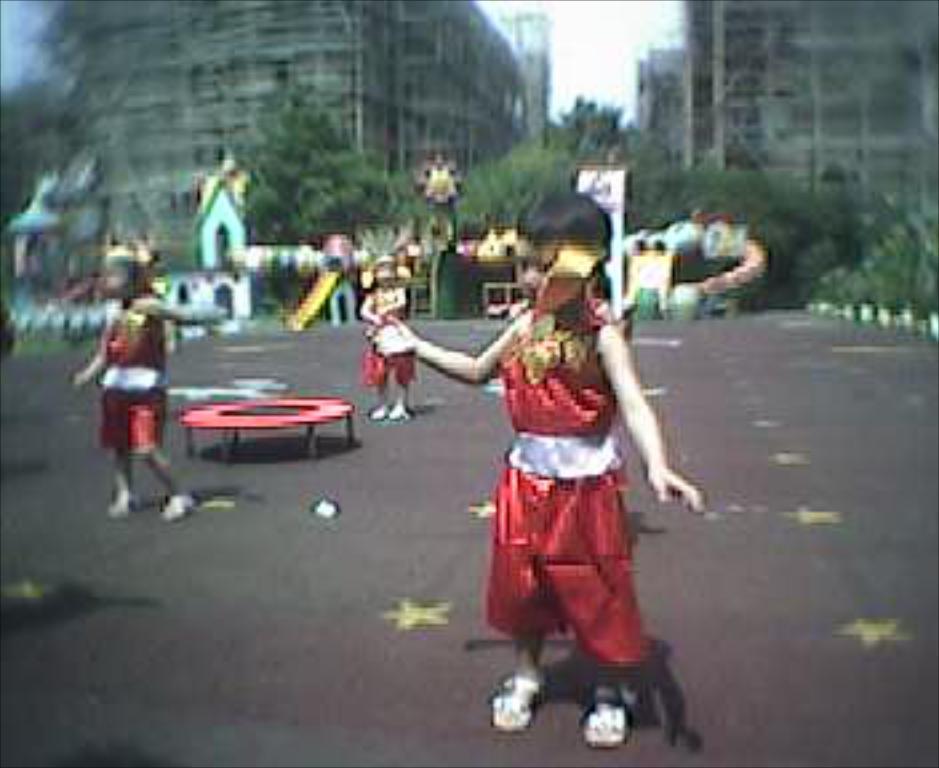Describe this image in one or two sentences. In this image we can see few people standing on the floor, there is a red color object which looks like a table and in the background there are buildings, trees and sky. 